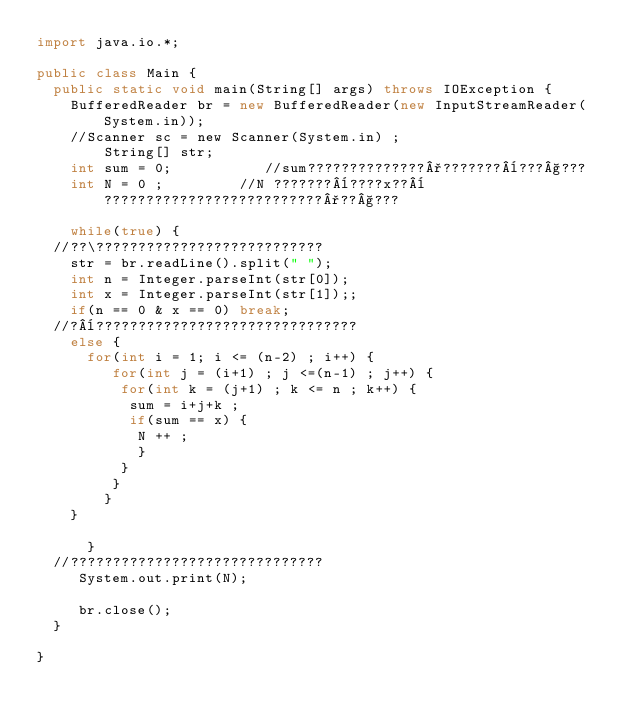<code> <loc_0><loc_0><loc_500><loc_500><_Java_>import java.io.*;

public class Main {
	public static void main(String[] args) throws IOException {
		BufferedReader br = new BufferedReader(new InputStreamReader(System.in));
		//Scanner sc = new Scanner(System.in) ;
        String[] str;
		int sum = 0;           //sum??????????????°???????¨???§???
		int N = 0 ;         //N ???????¨????x??¨??????????????????????????°??§???
		
		while(true) {
	//??\???????????????????????????
		str = br.readLine().split(" ");	
		int n = Integer.parseInt(str[0]);
		int x = Integer.parseInt(str[1]);;
		if(n == 0 & x == 0) break;
	//?¨???????????????????????????????	   
		else {
			for(int i = 1; i <= (n-2) ; i++) {
			   for(int j = (i+1) ; j <=(n-1) ; j++) {
				  for(int k = (j+1) ; k <= n ; k++) {
					 sum = i+j+k ;
					 if(sum == x) {
						N ++ ;
					  }  
				  }
			   }
		    }
		}
			
	    }
	//??????????????????????????????
	   System.out.print(N);
 
	   br.close();
	}

}</code> 